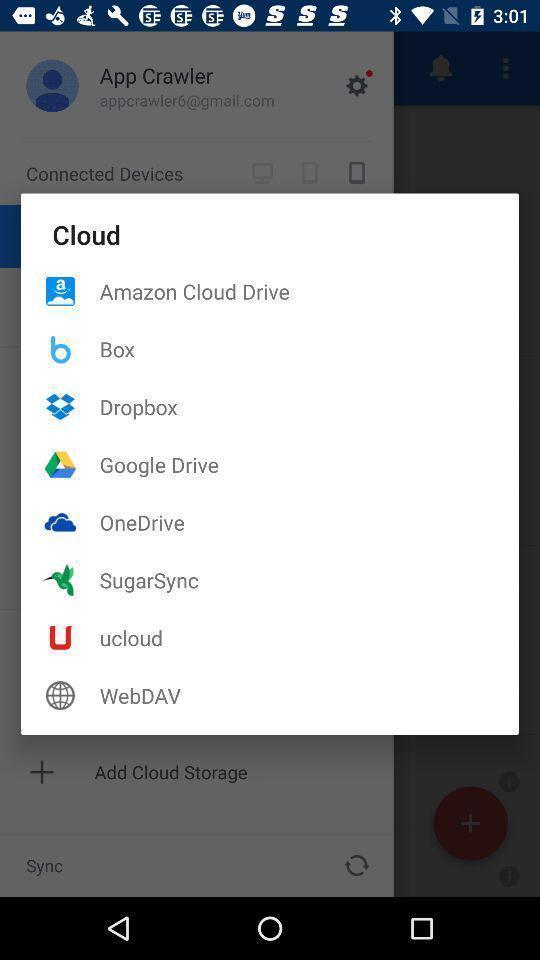Provide a detailed account of this screenshot. Popup to share with different options in the app. 